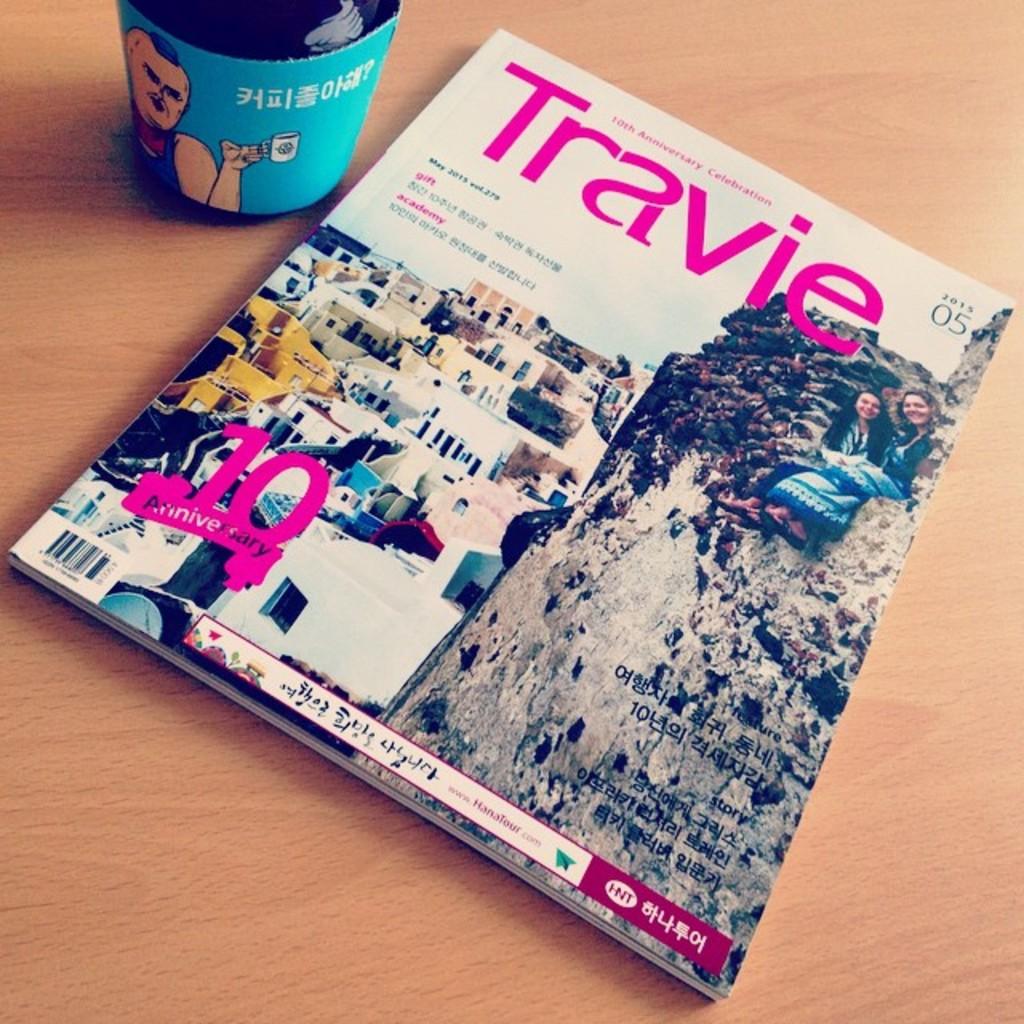What magazine is about to be read?
Provide a short and direct response. Travie. What anniversary is being celebrated on this cover?
Your answer should be very brief. 10. 